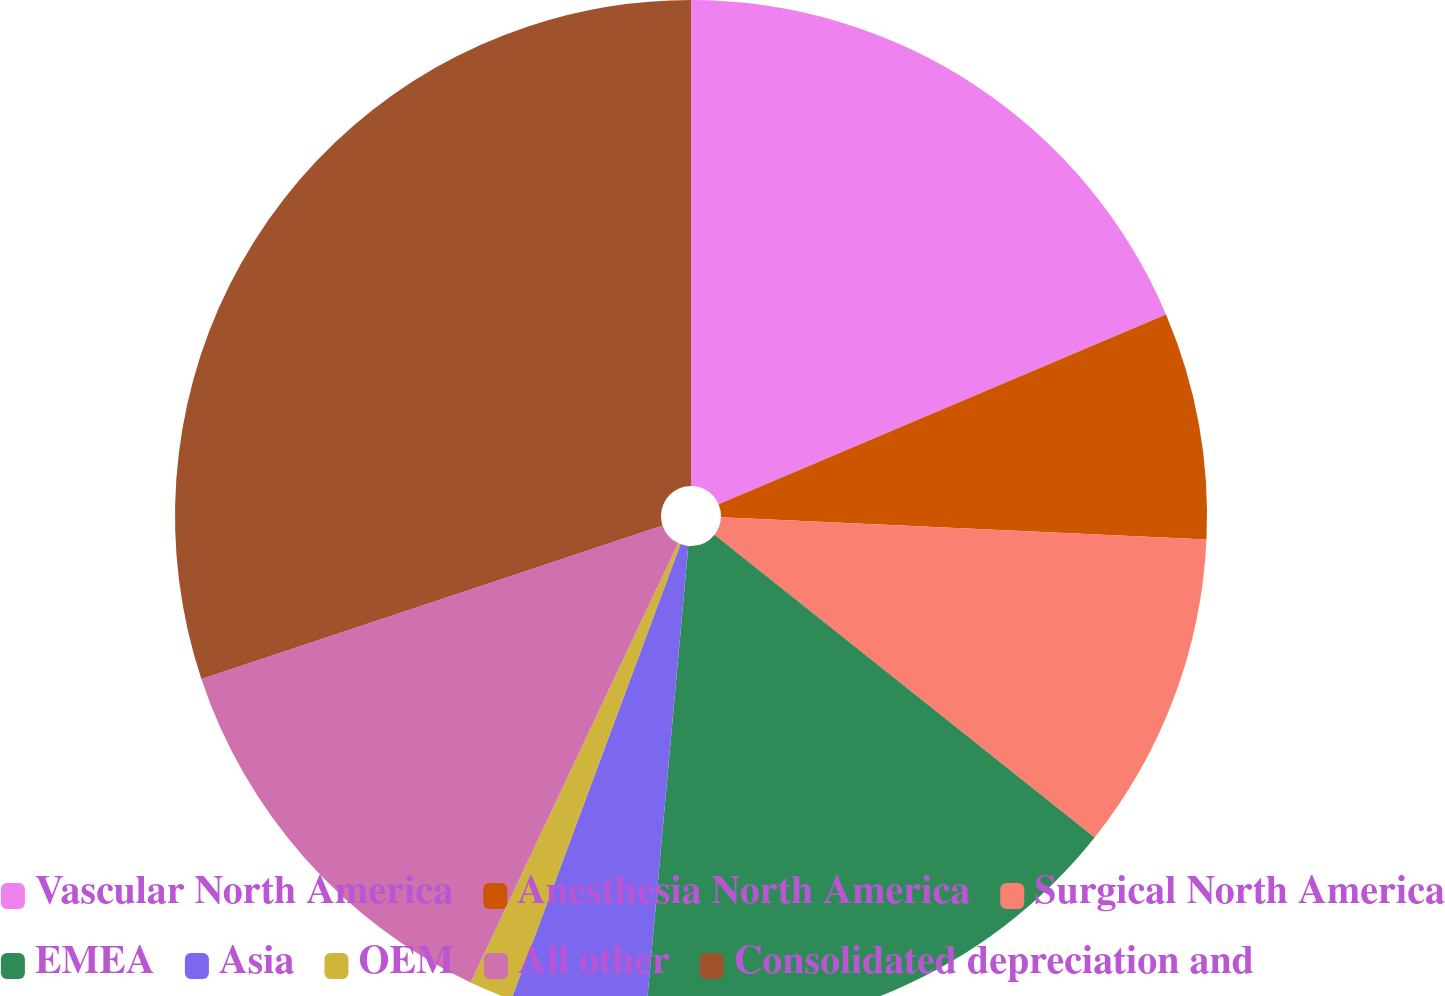<chart> <loc_0><loc_0><loc_500><loc_500><pie_chart><fcel>Vascular North America<fcel>Anesthesia North America<fcel>Surgical North America<fcel>EMEA<fcel>Asia<fcel>OEM<fcel>All other<fcel>Consolidated depreciation and<nl><fcel>18.61%<fcel>7.11%<fcel>9.98%<fcel>15.73%<fcel>4.23%<fcel>1.36%<fcel>12.86%<fcel>30.11%<nl></chart> 